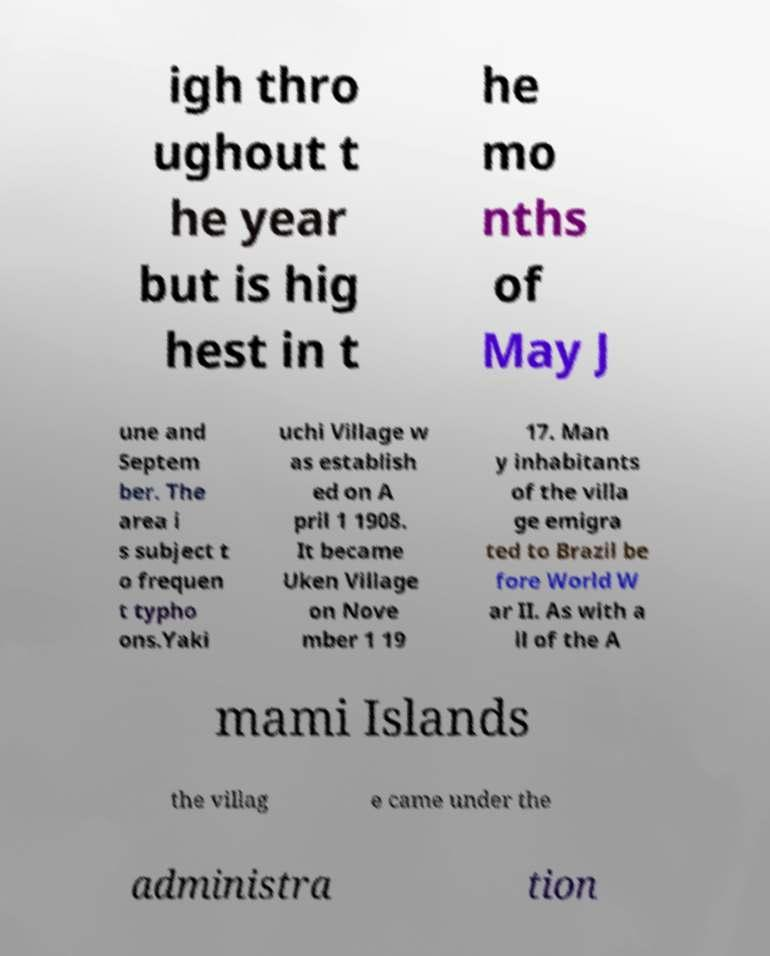Could you extract and type out the text from this image? igh thro ughout t he year but is hig hest in t he mo nths of May J une and Septem ber. The area i s subject t o frequen t typho ons.Yaki uchi Village w as establish ed on A pril 1 1908. It became Uken Village on Nove mber 1 19 17. Man y inhabitants of the villa ge emigra ted to Brazil be fore World W ar II. As with a ll of the A mami Islands the villag e came under the administra tion 